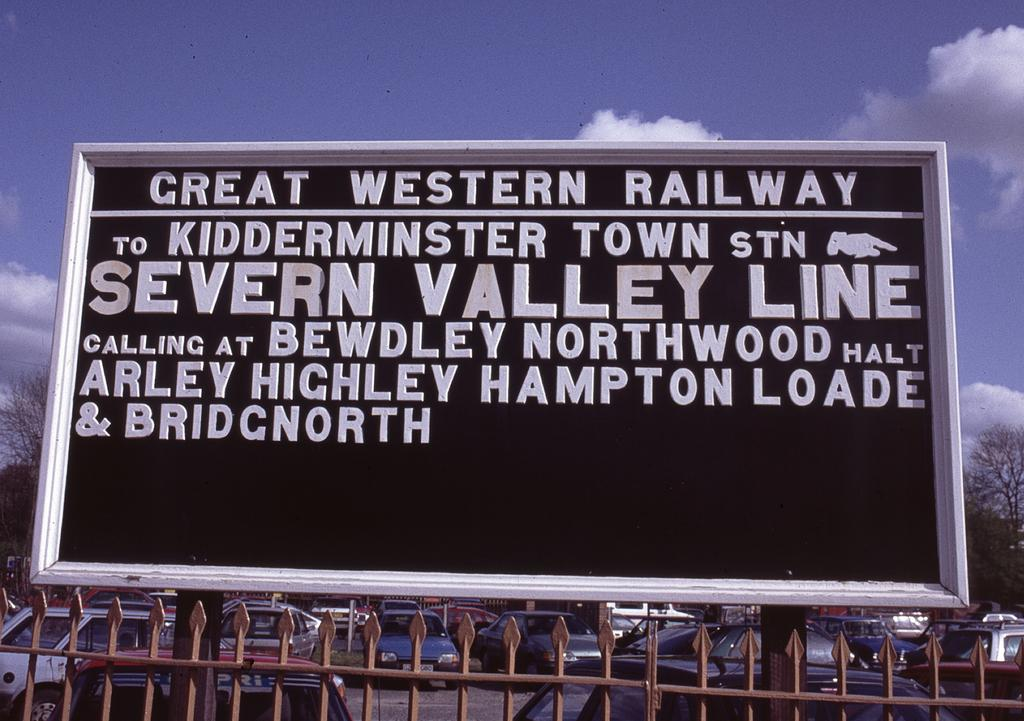<image>
Relay a brief, clear account of the picture shown. A sign for a railroad called Great Western Railway, the go to Kidderminster town station. 